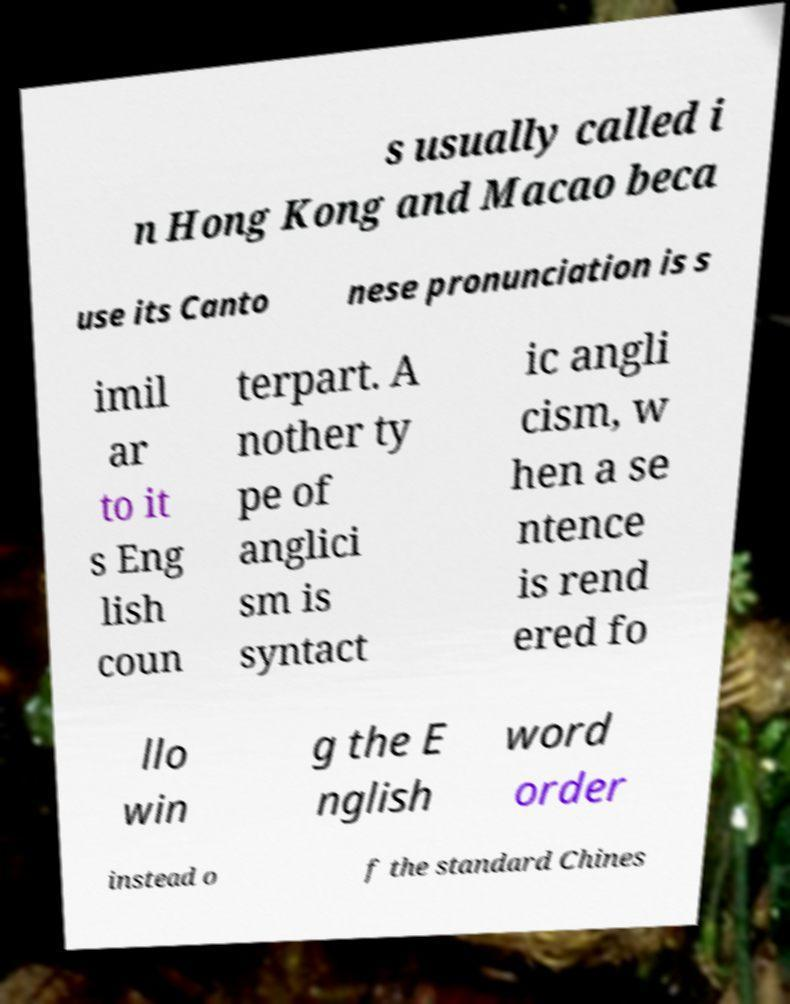Can you read and provide the text displayed in the image?This photo seems to have some interesting text. Can you extract and type it out for me? s usually called i n Hong Kong and Macao beca use its Canto nese pronunciation is s imil ar to it s Eng lish coun terpart. A nother ty pe of anglici sm is syntact ic angli cism, w hen a se ntence is rend ered fo llo win g the E nglish word order instead o f the standard Chines 